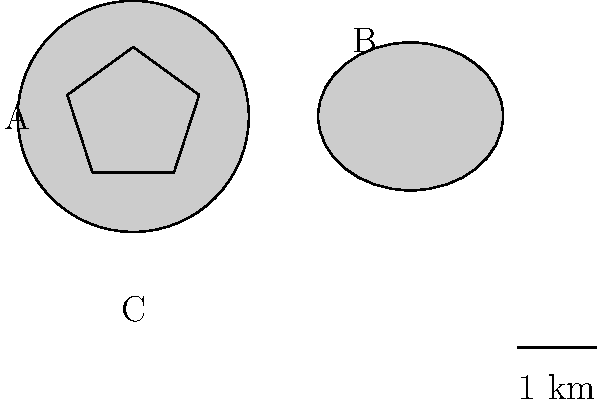During your exploration of Hawaii's volcanic formations, you encounter three distinct crater shapes as shown in the diagram above. Crater A is circular with a radius of 1 km, Crater B is elliptical with semi-major axis 1 km and semi-minor axis 0.8 km, and Crater C is a regular pentagon with side length 1 km. Rank these craters from largest to smallest surface area. To rank the craters by surface area, we need to calculate the area of each crater:

1. Crater A (Circle):
   Area = $\pi r^2 = \pi (1)^2 = \pi$ km²

2. Crater B (Ellipse):
   Area = $\pi ab$, where $a$ and $b$ are semi-major and semi-minor axes
   Area = $\pi(1)(0.8) = 0.8\pi$ km²

3. Crater C (Regular Pentagon):
   Area = $\frac{1}{4}\sqrt{25+10\sqrt{5}}s^2$, where $s$ is the side length
   Area = $\frac{1}{4}\sqrt{25+10\sqrt{5}}(1)^2 \approx 2.38$ km²

Comparing these areas:
$\pi \approx 3.14$ km² (Crater A)
$0.8\pi \approx 2.51$ km² (Crater B)
$2.38$ km² (Crater C)

Therefore, the ranking from largest to smallest surface area is:
Crater A > Crater B > Crater C
Answer: A > B > C 